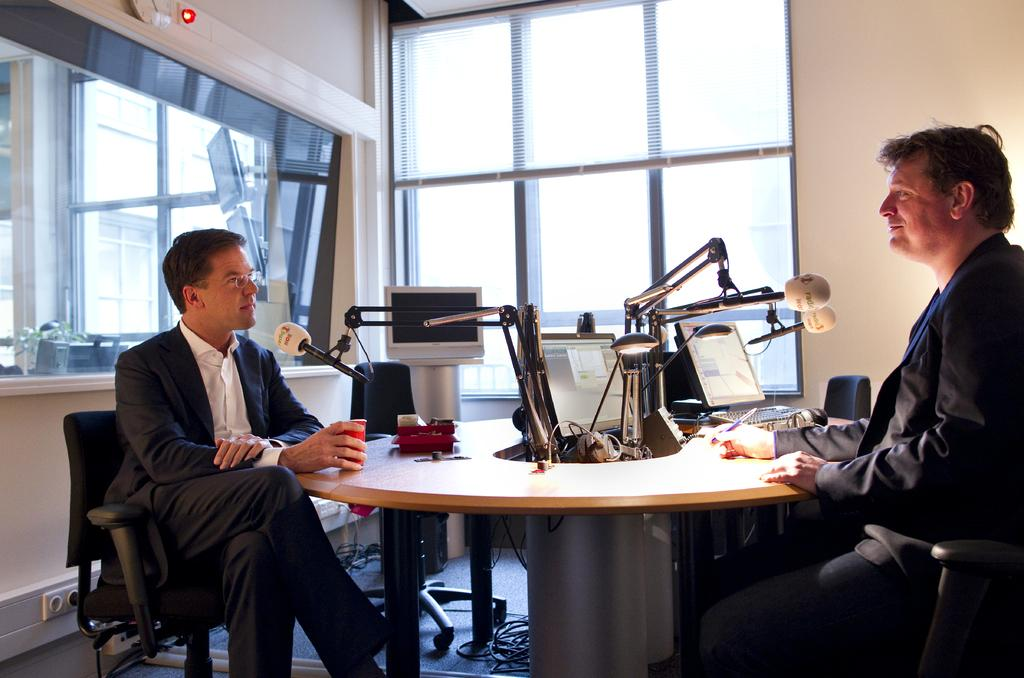How many people are in the image? There are two persons in the image. What are the persons doing in the image? The persons are sitting on chairs and holding their hands. What is present on the table in the image? There is a table in the image. What can be seen in the middle of the image? There is a light in the middle of the image. What type of window is visible in the image? There is a glass window in the image. What type of soup is being served in the image? A: There is no soup present in the image. What type of animals can be seen in the zoo in the image? There is no zoo present in the image. 